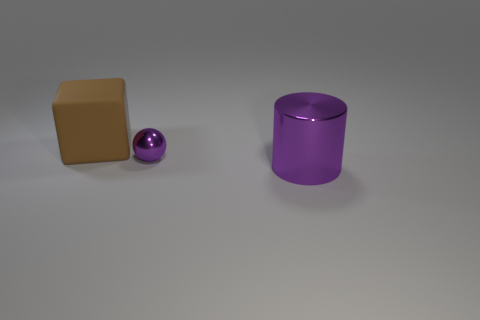Add 1 small purple objects. How many objects exist? 4 Subtract all spheres. How many objects are left? 2 Add 3 brown matte objects. How many brown matte objects are left? 4 Add 2 balls. How many balls exist? 3 Subtract 0 blue cylinders. How many objects are left? 3 Subtract all blocks. Subtract all small shiny things. How many objects are left? 1 